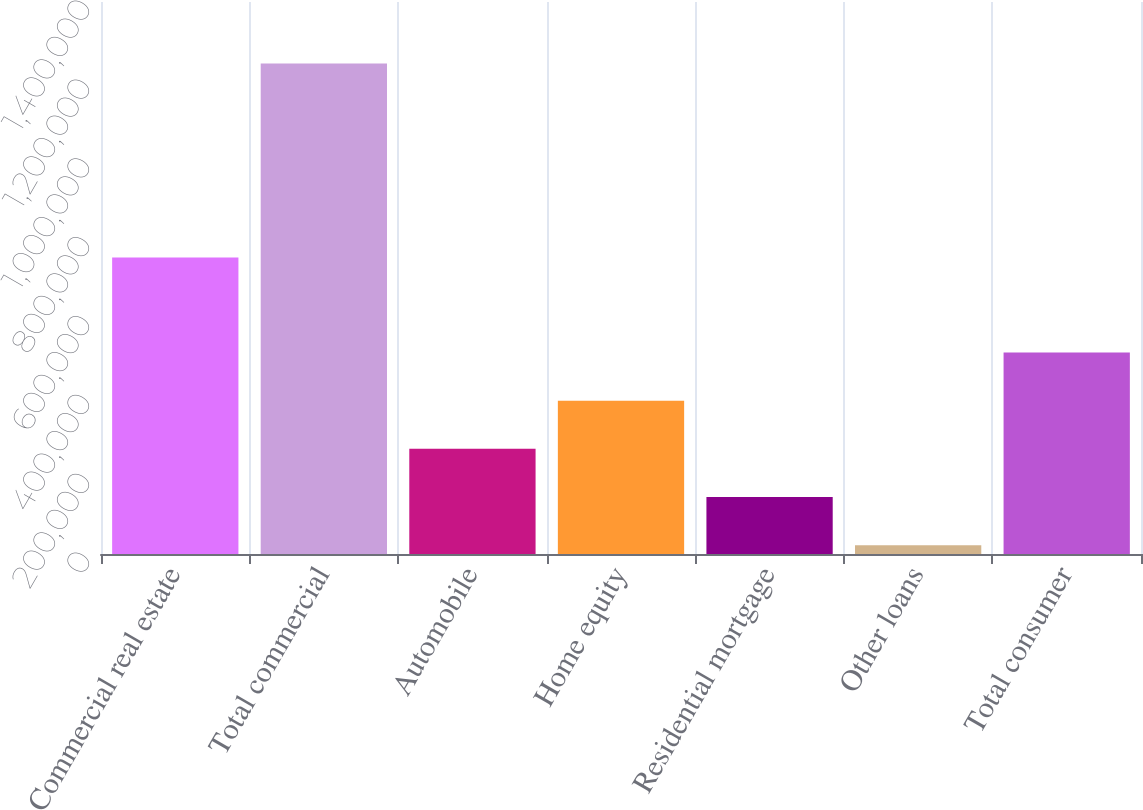Convert chart to OTSL. <chart><loc_0><loc_0><loc_500><loc_500><bar_chart><fcel>Commercial real estate<fcel>Total commercial<fcel>Automobile<fcel>Home equity<fcel>Residential mortgage<fcel>Other loans<fcel>Total consumer<nl><fcel>751875<fcel>1.24408e+06<fcel>266821<fcel>388978<fcel>144663<fcel>22506<fcel>511136<nl></chart> 